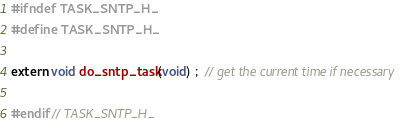<code> <loc_0><loc_0><loc_500><loc_500><_C_>#ifndef TASK_SNTP_H_
#define TASK_SNTP_H_

extern void do_sntp_task(void) ;  // get the current time if necessary

#endif // TASK_SNTP_H_
</code> 